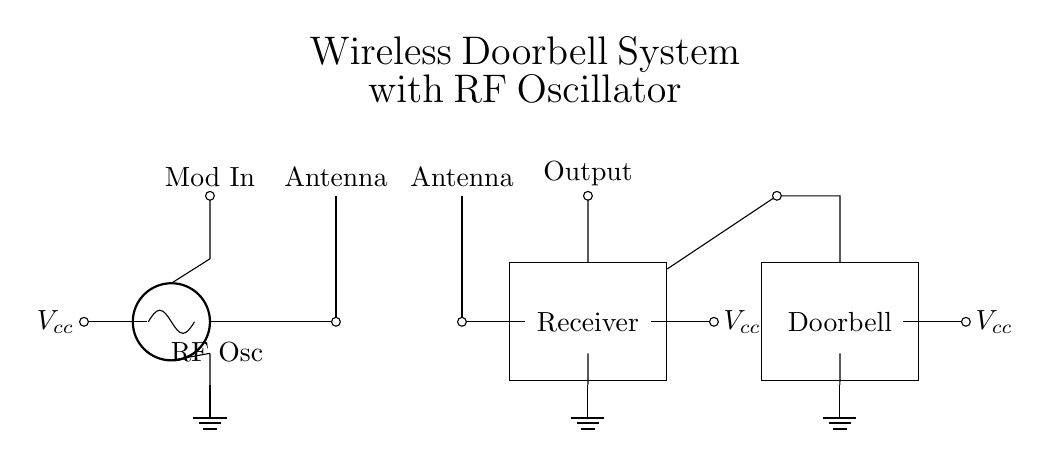What type of oscillator is used in this circuit? The circuit diagram specifies "RF Osc" as the component labeled as the oscillator, indicating that it is a radio frequency oscillator.
Answer: RF oscillator What component connects the transmitter to the antenna? In the circuit, the connection from the oscillator to the antenna is shown with a short line labeled as an output, indicating that the oscillator output is connected to the antenna.
Answer: Short line What is the purpose of the receiver block? The receiver block is responsible for receiving the signals that are transmitted by the RF oscillator, and it processes them for output.
Answer: Signal reception How many antennas are present in the circuit? The circuit diagram shows one antenna for the RF oscillator and one antenna for the receiver, totaling two antennas.
Answer: Two What is the label of the output from the receiver block? The output from the receiver block is labeled as "Output" in the circuit, showing that it is the processed signal output.
Answer: Output What type of power supply is shown for the doorbell? The circuit shows a power connection to the doorbell labeled as "Vcc", indicating a positive voltage power supply for the doorbell circuit.
Answer: Vcc Why is modulation input present in the circuit? The modulation input is present to allow external control signals or modifications that can influence the transmission characteristics of the RF oscillator, thus adjusting the transmitted signal.
Answer: Control signal 